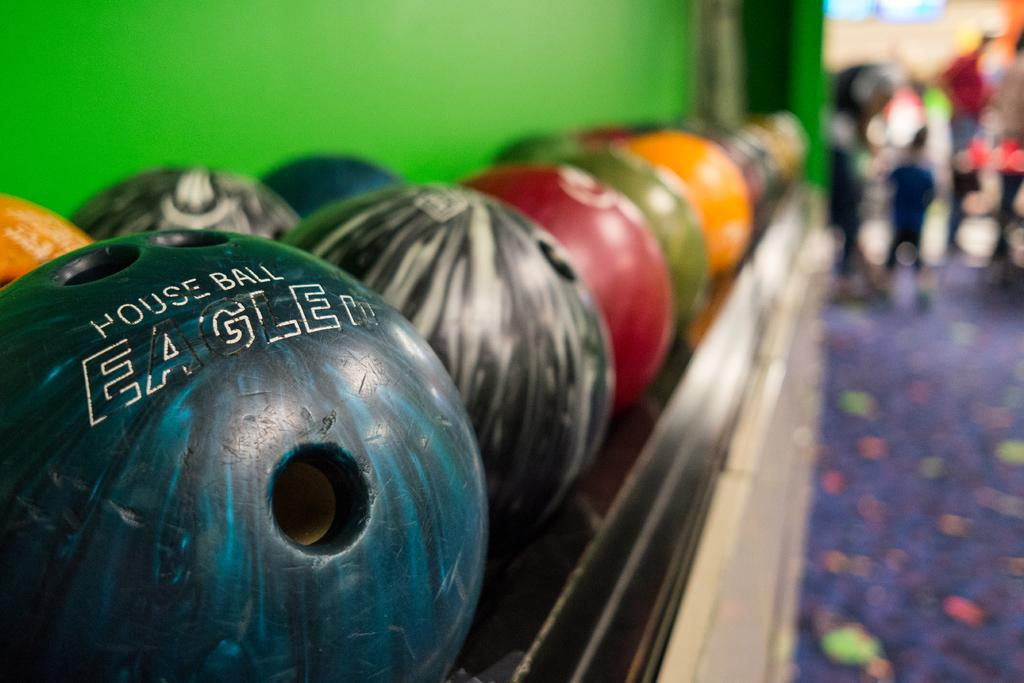What objects are on the shelf in the image? There are balls on a shelf in the image. What type of flooring is visible in the image? There is a carpet visible in the image. What color is the wall in the image? The wall in the image is green. How would you describe the background of the image? The background of the image is blurry. What verse can be heard recited by the kittens in the image? There are no kittens present in the image, and therefore no verses can be heard. 